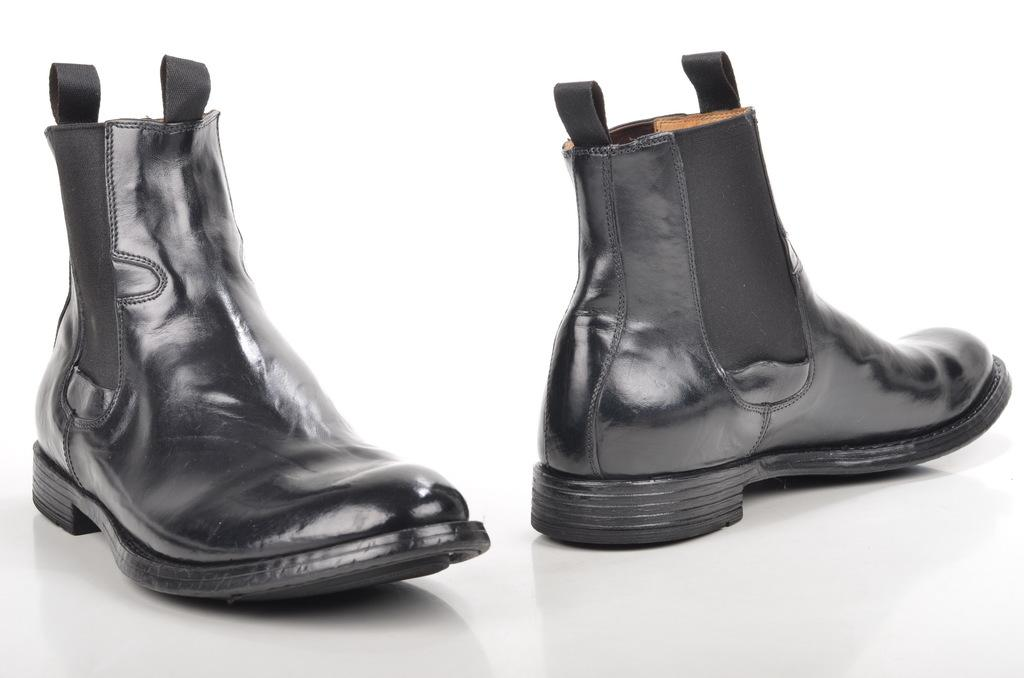What type of footwear is featured in the image? There are two black boots in the image. What color is the background of the boots? The background of the boots is white. What type of flag is visible in the image? There is no flag present in the image; it only features two black boots with a white background. 